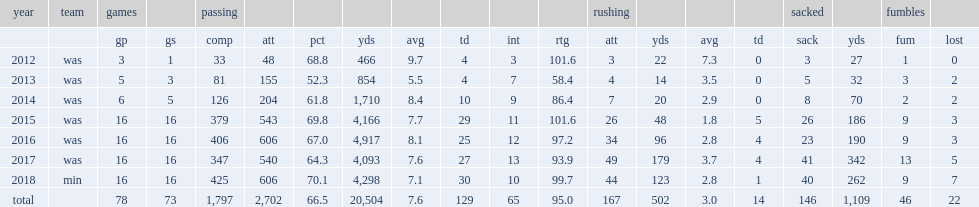How many passing yards did cousins finish the season with a career-high passing yards? 4917.0. 